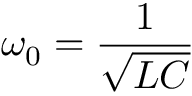Convert formula to latex. <formula><loc_0><loc_0><loc_500><loc_500>\omega _ { 0 } = { \frac { 1 } { \sqrt { L C } } }</formula> 